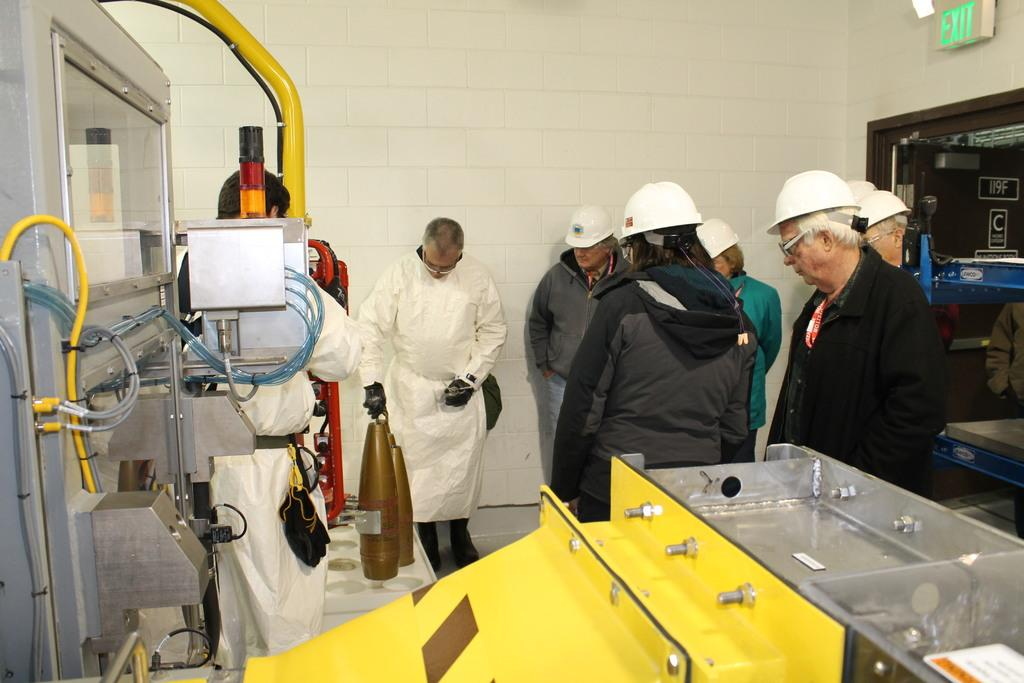What can be seen in the image involving multiple individuals? There is a group of people in the image. What else is present in the image besides the group of people? There are machines in the image. Where is the door located in the image? The door is on the right side of the image. What is located next to the door on the right side of the image? There is an exit board on the right side of the image. What can be seen in the background of the image? There is a wall in the background of the image. What type of clover can be seen growing on the wall in the image? There is no clover present in the image; only a wall is visible in the background. What color are the flowers on the machines in the image? There are no flowers present on the machines in the image. 